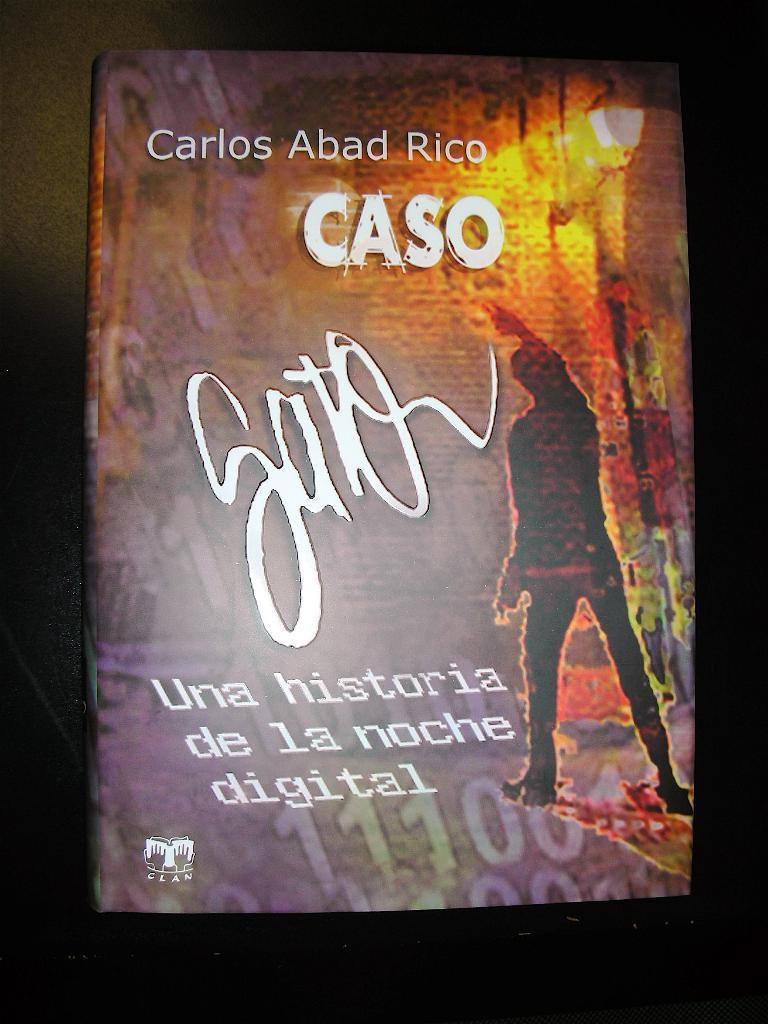<image>
Relay a brief, clear account of the picture shown. A poster that reads Caso with the words Carlos Abad Rico above it 